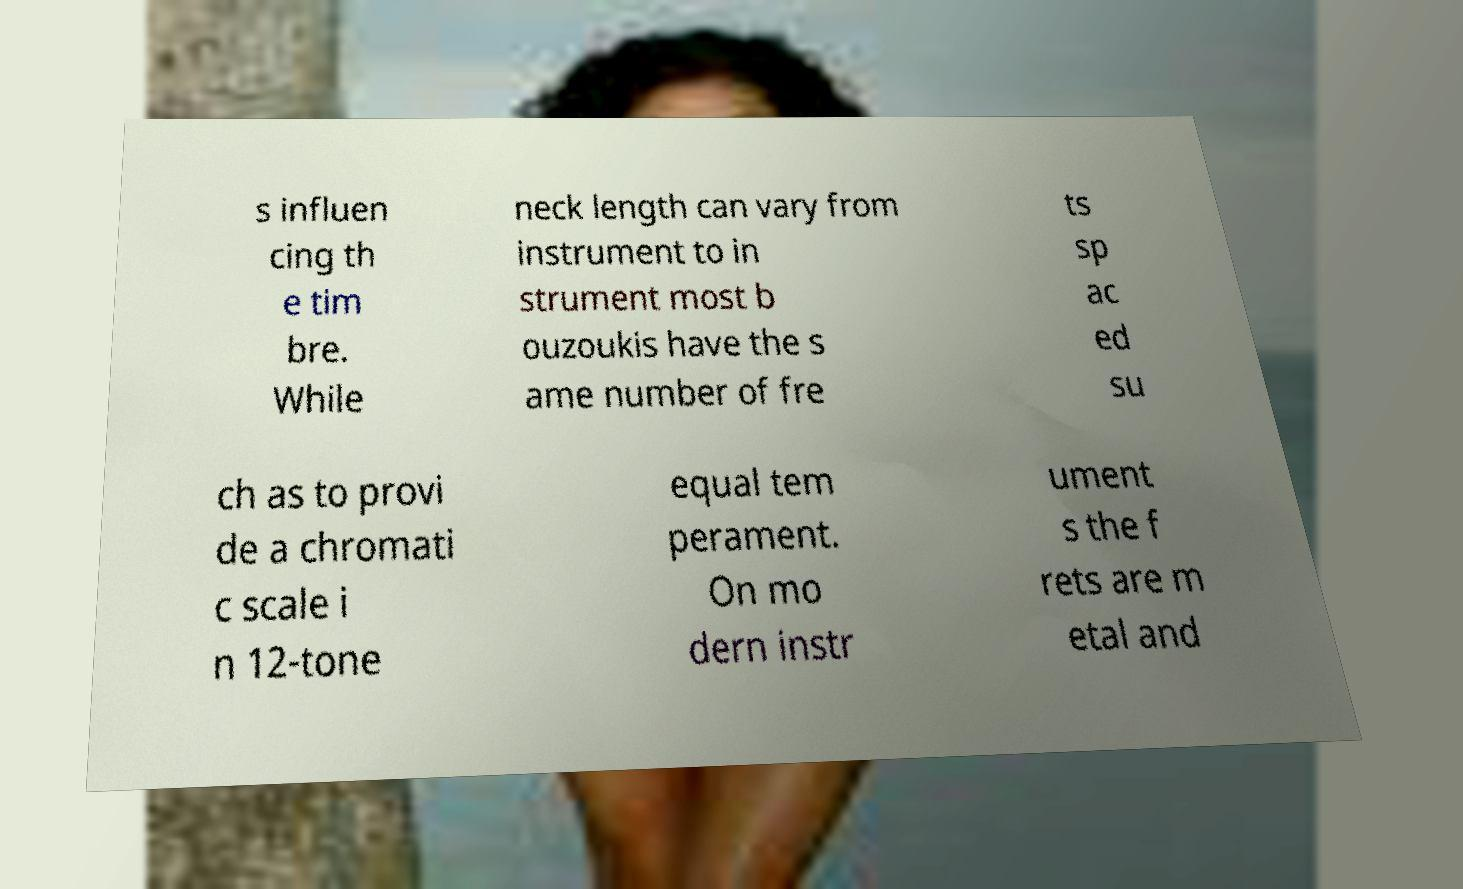Could you extract and type out the text from this image? s influen cing th e tim bre. While neck length can vary from instrument to in strument most b ouzoukis have the s ame number of fre ts sp ac ed su ch as to provi de a chromati c scale i n 12-tone equal tem perament. On mo dern instr ument s the f rets are m etal and 